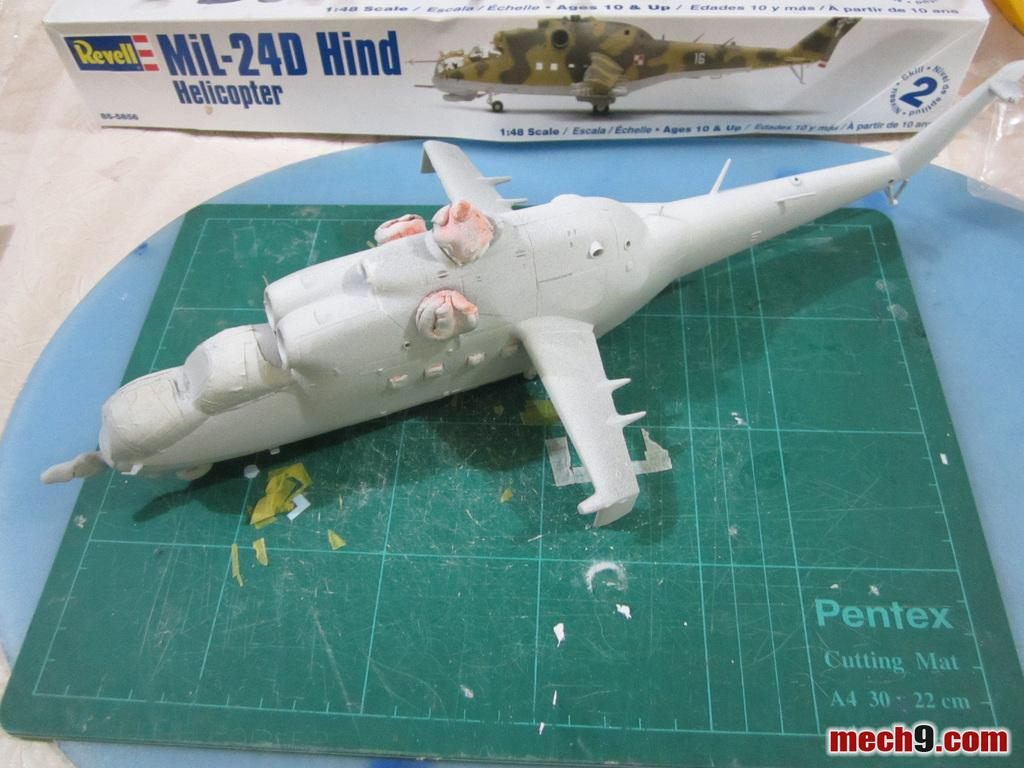<image>
Write a terse but informative summary of the picture. A Revell model helicopter is being constructed on a Pentex brand cutting mat. 